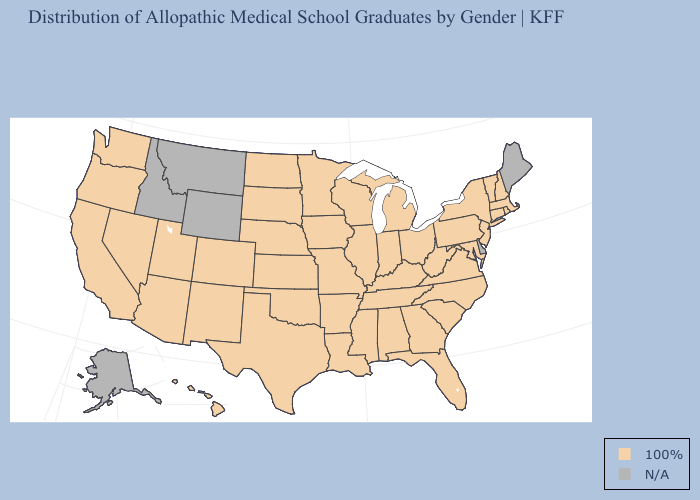Does the map have missing data?
Give a very brief answer. Yes. Name the states that have a value in the range N/A?
Be succinct. Alaska, Delaware, Idaho, Maine, Montana, Wyoming. Is the legend a continuous bar?
Answer briefly. No. Name the states that have a value in the range N/A?
Short answer required. Alaska, Delaware, Idaho, Maine, Montana, Wyoming. Among the states that border Pennsylvania , which have the lowest value?
Quick response, please. Maryland, New Jersey, New York, Ohio, West Virginia. Among the states that border Wisconsin , which have the lowest value?
Concise answer only. Illinois, Iowa, Michigan, Minnesota. How many symbols are there in the legend?
Write a very short answer. 2. Is the legend a continuous bar?
Short answer required. No. Which states hav the highest value in the South?
Give a very brief answer. Alabama, Arkansas, Florida, Georgia, Kentucky, Louisiana, Maryland, Mississippi, North Carolina, Oklahoma, South Carolina, Tennessee, Texas, Virginia, West Virginia. Name the states that have a value in the range 100%?
Be succinct. Alabama, Arizona, Arkansas, California, Colorado, Connecticut, Florida, Georgia, Hawaii, Illinois, Indiana, Iowa, Kansas, Kentucky, Louisiana, Maryland, Massachusetts, Michigan, Minnesota, Mississippi, Missouri, Nebraska, Nevada, New Hampshire, New Jersey, New Mexico, New York, North Carolina, North Dakota, Ohio, Oklahoma, Oregon, Pennsylvania, Rhode Island, South Carolina, South Dakota, Tennessee, Texas, Utah, Vermont, Virginia, Washington, West Virginia, Wisconsin. What is the value of North Carolina?
Short answer required. 100%. Name the states that have a value in the range N/A?
Keep it brief. Alaska, Delaware, Idaho, Maine, Montana, Wyoming. Name the states that have a value in the range N/A?
Concise answer only. Alaska, Delaware, Idaho, Maine, Montana, Wyoming. Is the legend a continuous bar?
Concise answer only. No. What is the value of North Dakota?
Concise answer only. 100%. 